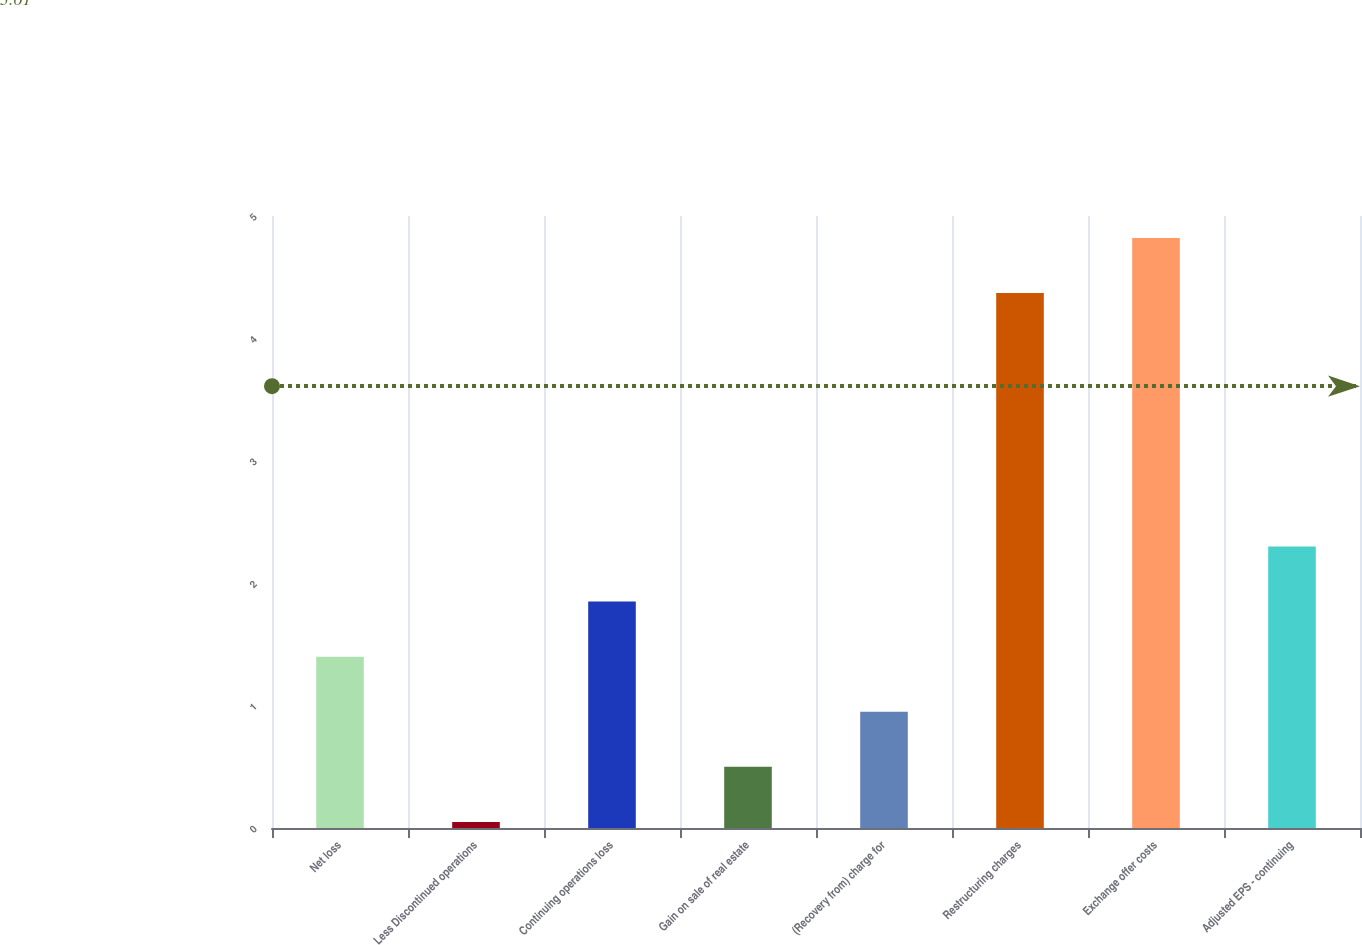Convert chart. <chart><loc_0><loc_0><loc_500><loc_500><bar_chart><fcel>Net loss<fcel>Less Discontinued operations<fcel>Continuing operations loss<fcel>Gain on sale of real estate<fcel>(Recovery from) charge for<fcel>Restructuring charges<fcel>Exchange offer costs<fcel>Adjusted EPS - continuing<nl><fcel>1.4<fcel>0.05<fcel>1.85<fcel>0.5<fcel>0.95<fcel>4.37<fcel>4.82<fcel>2.3<nl></chart> 